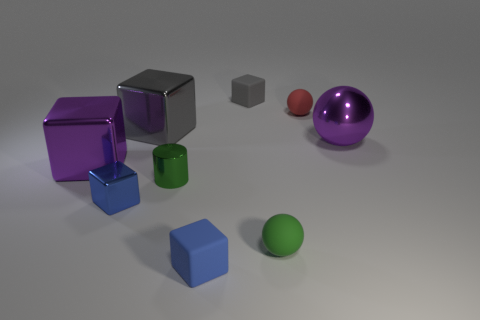Subtract all purple cubes. How many cubes are left? 4 Subtract all blue matte cubes. How many cubes are left? 4 Subtract 1 blocks. How many blocks are left? 4 Subtract all green blocks. Subtract all green spheres. How many blocks are left? 5 Add 1 blue blocks. How many objects exist? 10 Subtract all cylinders. How many objects are left? 8 Add 5 shiny blocks. How many shiny blocks are left? 8 Add 4 large brown shiny spheres. How many large brown shiny spheres exist? 4 Subtract 1 gray blocks. How many objects are left? 8 Subtract all tiny cylinders. Subtract all blue objects. How many objects are left? 6 